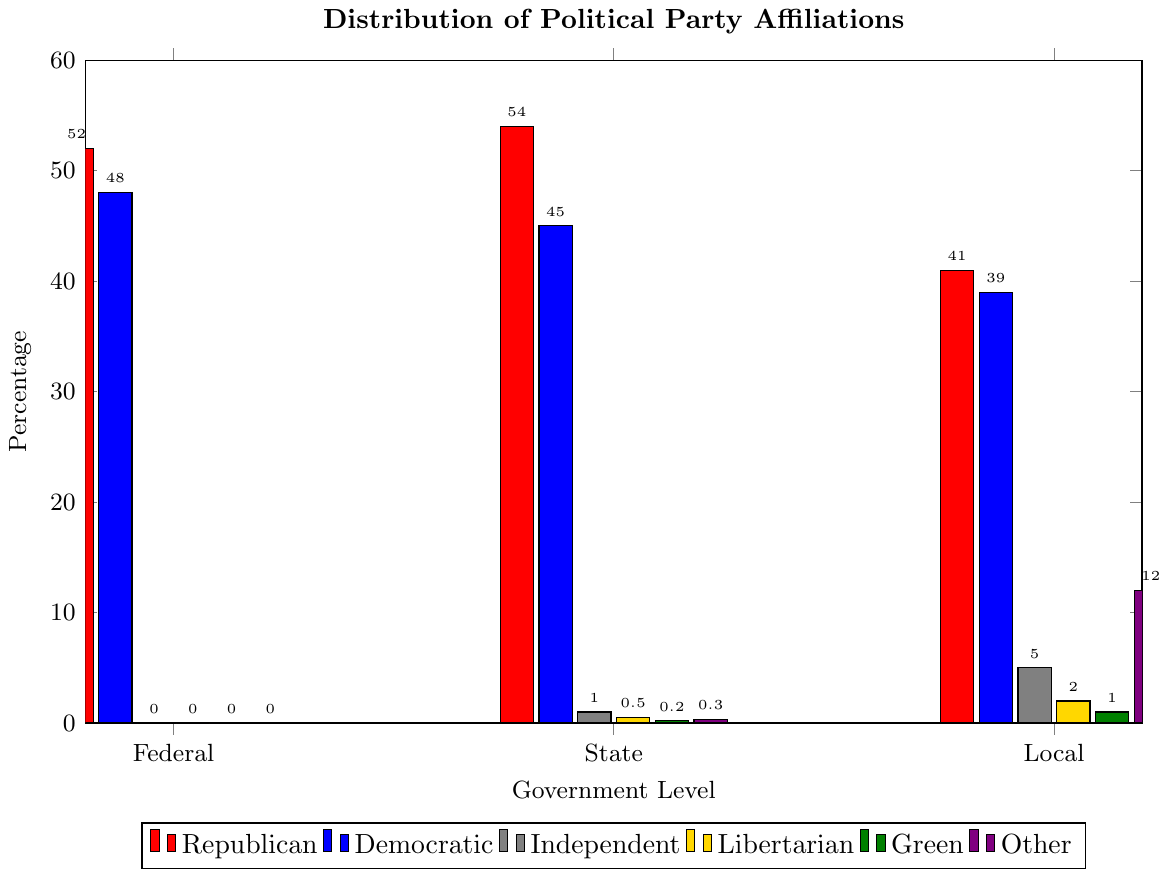Which government level has the highest percentage of Republican officials? The bar with the highest height among Republican officials (red color) indicates the government level with the highest percentage. By visually inspecting, the State level has the highest bar at 54%.
Answer: State How many more Democratic officials are there at the Federal level compared to the State level? The percentage of Democratic officials at the Federal level is 48% and at the State level is 45%. Subtract the State percentage from the Federal percentage: 48% - 45% = 3%.
Answer: 3% What is the total percentage of Independent and Libertarian officials at the Local level? The percentage of Independent officials at the Local level is 5%, and the percentage of Libertarian officials at the Local level is 2%. Add these two values: 5% + 2% = 7%.
Answer: 7% Which political party has the lowest representation at the Federal level? By comparing the heights of the bars for different political parties at the Federal level, the Green party (dark green color) has the shortest bar with 0%.
Answer: Green Do Republicans have a higher percentage representation at the State level compared to the Local level? Compare the heights of the red bars for Republicans at the State (54%) and Local (41%) levels. Since 54% (State) is greater than 41% (Local), Republicans have a higher representation at the State level.
Answer: Yes How much taller is the "Other" category at the Local level compared to the State level? At the Local level, the "Other" party has a representation of 12%, and at the State level, it has 0.3%. Subtract the State percentage from the Local percentage: 12% - 0.3% = 11.7%.
Answer: 11.7% Which political parties have equal representation at the Federal level? Both the Independent, Libertarian, Green, and Other parties have a representation of 0% at the Federal level.
Answer: Independent, Libertarian, Green, Other What is the average percentage representation of the Democratic party across all three government levels? The percentages for the Democratic party are 48% (Federal), 45% (State), and 39% (Local). Calculate the average: (48% + 45% + 39%) / 3 = 44%.
Answer: 44% Which level of government has the most diverse political representation based on the number of different parties represented? The Local level has representatives from all six categories, whereas the Federal and State levels have fewer categories represented.
Answer: Local By how much does the percentage of Republican officials at the State level exceed the percentage of Democratic officials at the same level? At the State level, Republicans have 54% and Democrats have 45%. Subtract the Democratic percentage from the Republican percentage: 54% - 45% = 9%.
Answer: 9% 